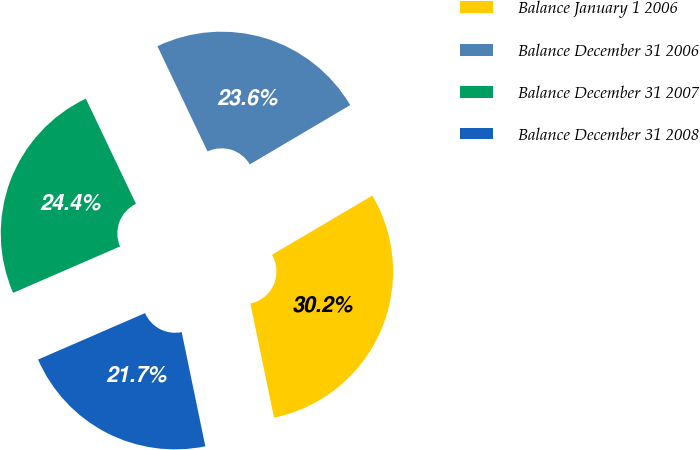Convert chart to OTSL. <chart><loc_0><loc_0><loc_500><loc_500><pie_chart><fcel>Balance January 1 2006<fcel>Balance December 31 2006<fcel>Balance December 31 2007<fcel>Balance December 31 2008<nl><fcel>30.23%<fcel>23.59%<fcel>24.44%<fcel>21.73%<nl></chart> 